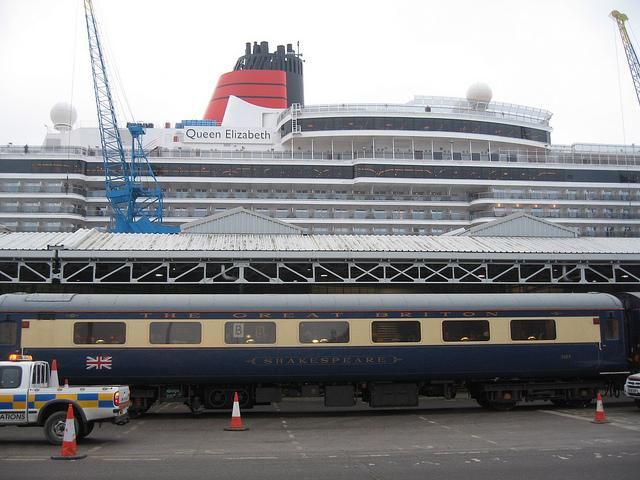The person whose name appears at the top is a descendant of whom? Please explain your reasoning. henry viii. The other options aren't english. 